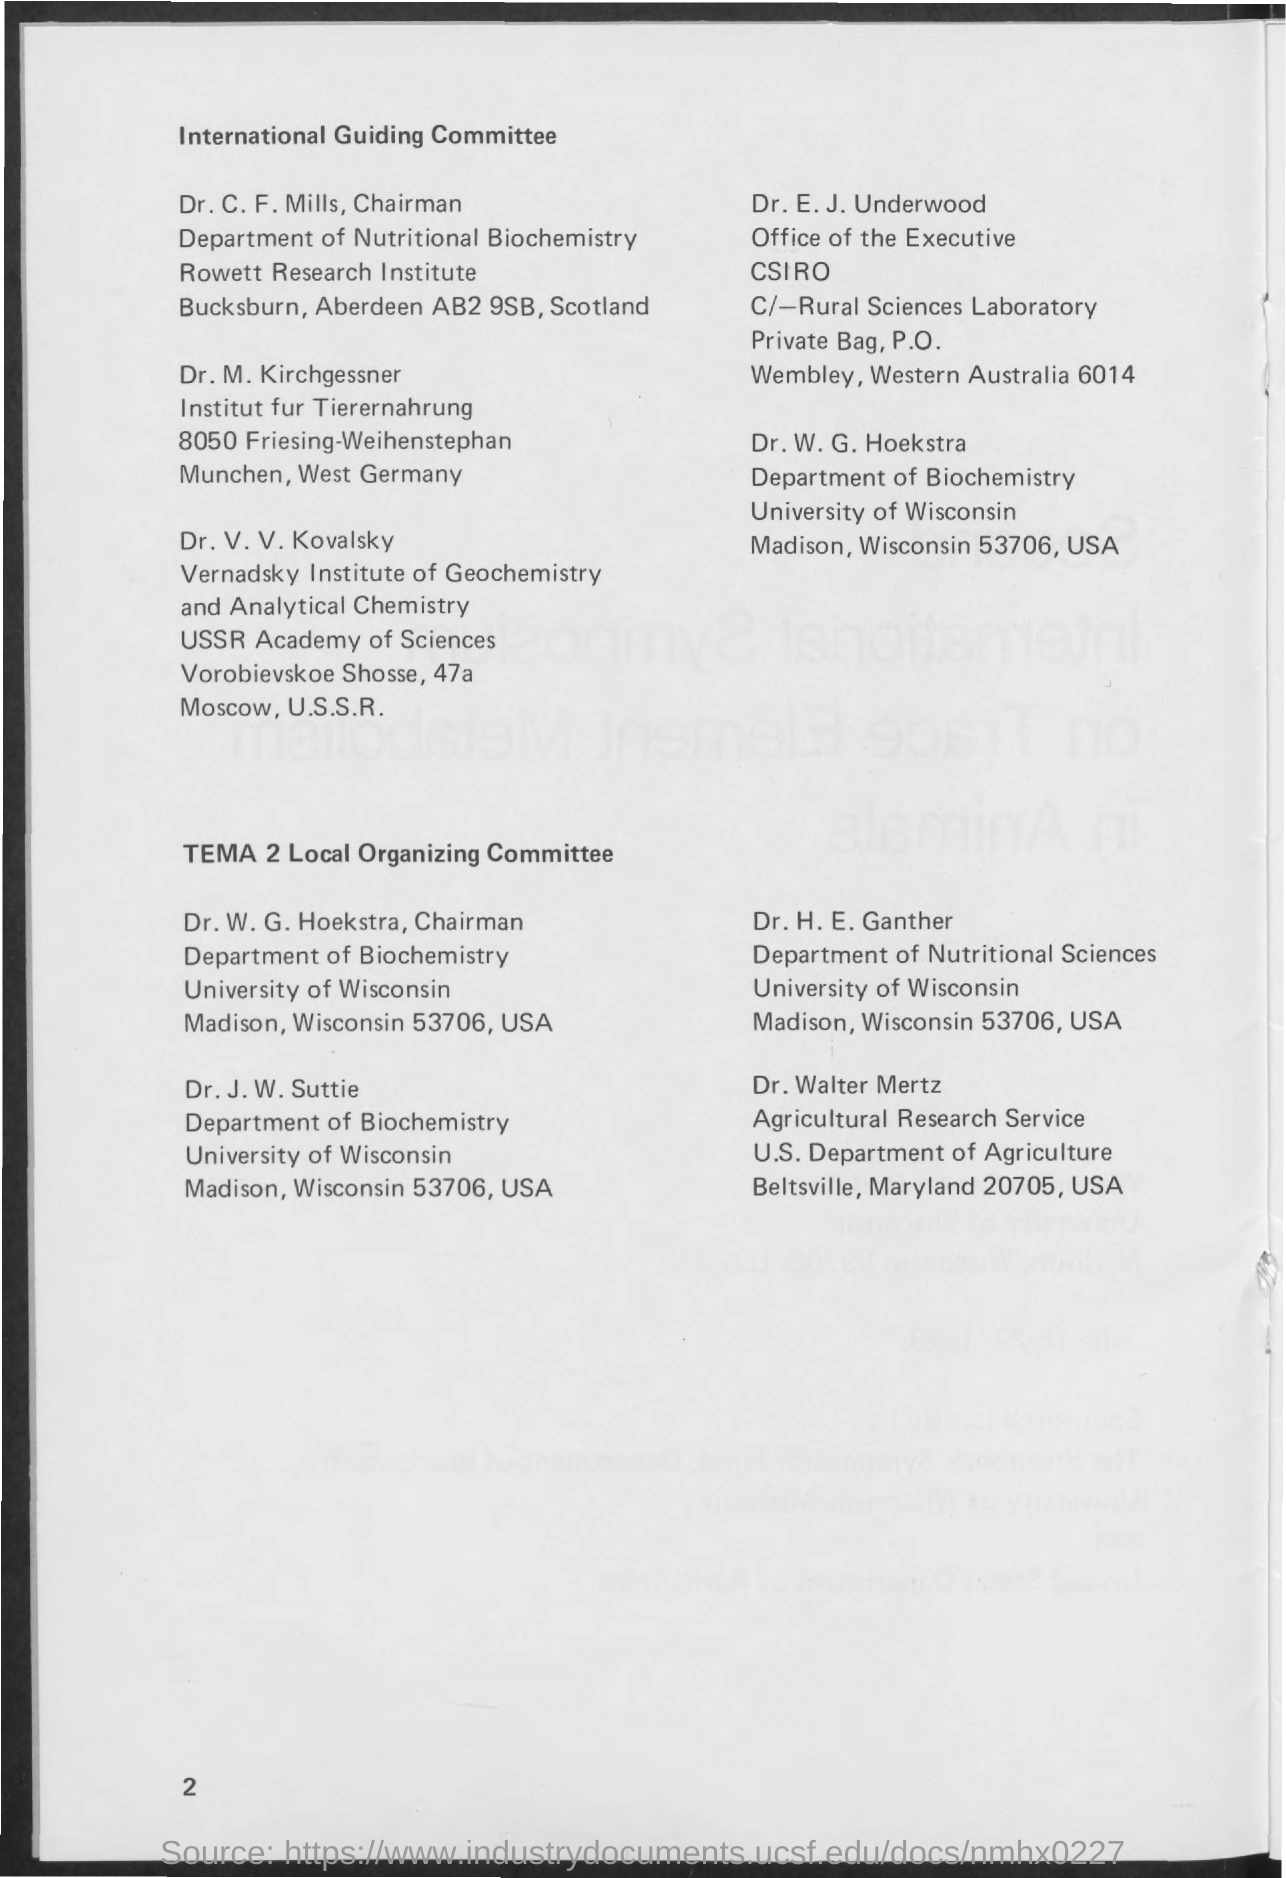Who is the member of 'International Guiding Committee' from Scotland?
Give a very brief answer. Dr. C. F. Mills. Who is the member of 'International Guiding Committee' from Australia?
Provide a succinct answer. Dr. E. J. Underwood. Who is the member of 'International Guiding Committee' from USA?
Ensure brevity in your answer.  Dr. W. G. Hoekstra. Who is the member of 'TEMA 2 Local Organizing Committee' from Maryland 20705,USA?
Offer a terse response. Dr. Walter Mertz. 